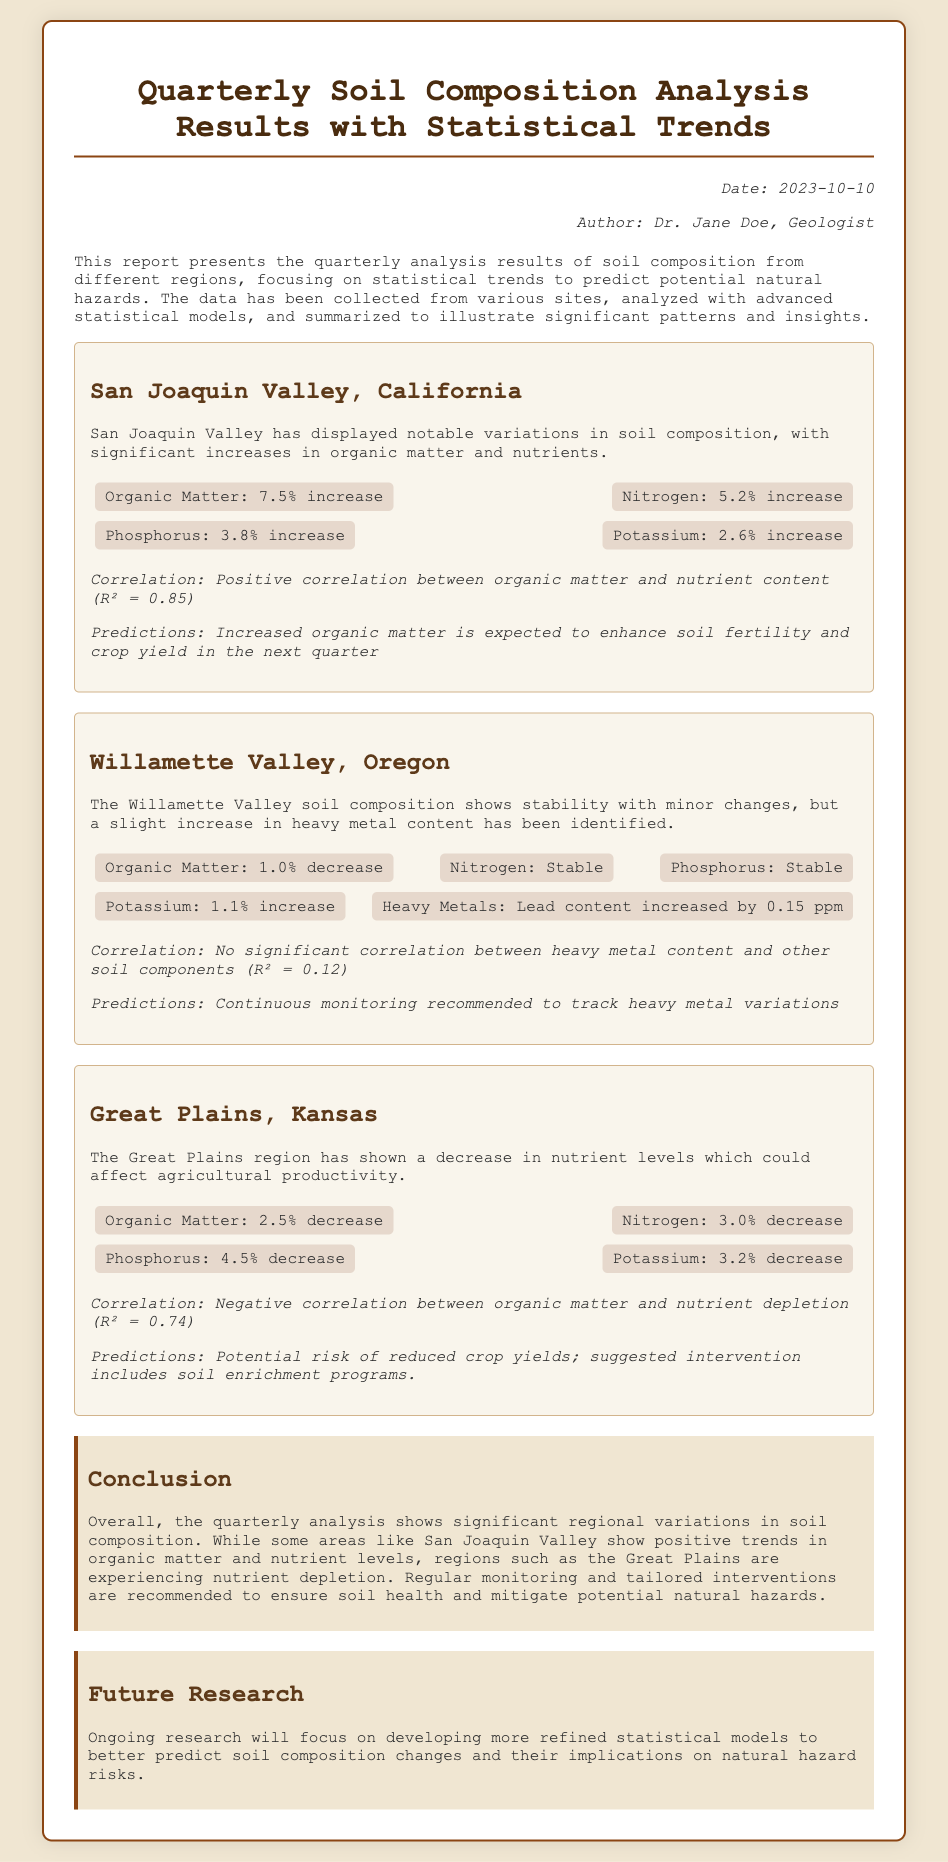What is the date of the report? The date is provided in the meta section of the document.
Answer: 2023-10-10 Who is the author of the report? The author's name is mentioned in the meta section.
Answer: Dr. Jane Doe What is the increase in organic matter for San Joaquin Valley? The increase in organic matter is stated clearly in the San Joaquin Valley section.
Answer: 7.5% increase What is the correlation coefficient for organic matter and nutrient content in San Joaquin Valley? The correlation coefficient is detailed in the statistical trends for San Joaquin Valley.
Answer: R² = 0.85 What was the percentage decrease in organic matter for the Great Plains region? The percentage decrease is explicitly mentioned in the Great Plains section.
Answer: 2.5% decrease What is the recommendation for the Willamette Valley regarding heavy metal content? The recommendation is indicated in the statistical trends section for the Willamette Valley.
Answer: Continuous monitoring What trend was observed in the Great Plains regarding nutrient levels? The trend regarding nutrient levels is summarized in the Great Plains section.
Answer: Decrease in nutrient levels What is the focus of future research mentioned in the report? The focus of future research is outlined in the Future Research section.
Answer: Developing more refined statistical models 